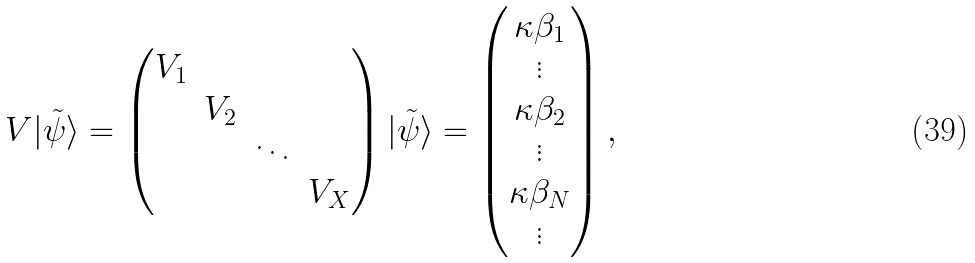Convert formula to latex. <formula><loc_0><loc_0><loc_500><loc_500>V | \tilde { \psi } \rangle = \left ( \begin{matrix} V _ { 1 } & & & \\ & V _ { 2 } & & \\ & & \ddots & \\ & & & V _ { X } \end{matrix} \right ) | \tilde { \psi } \rangle = \left ( \begin{matrix} \kappa \beta _ { 1 } \\ \vdots \\ \kappa \beta _ { 2 } \\ \vdots \\ \kappa \beta _ { N } \\ \vdots \end{matrix} \right ) ,</formula> 